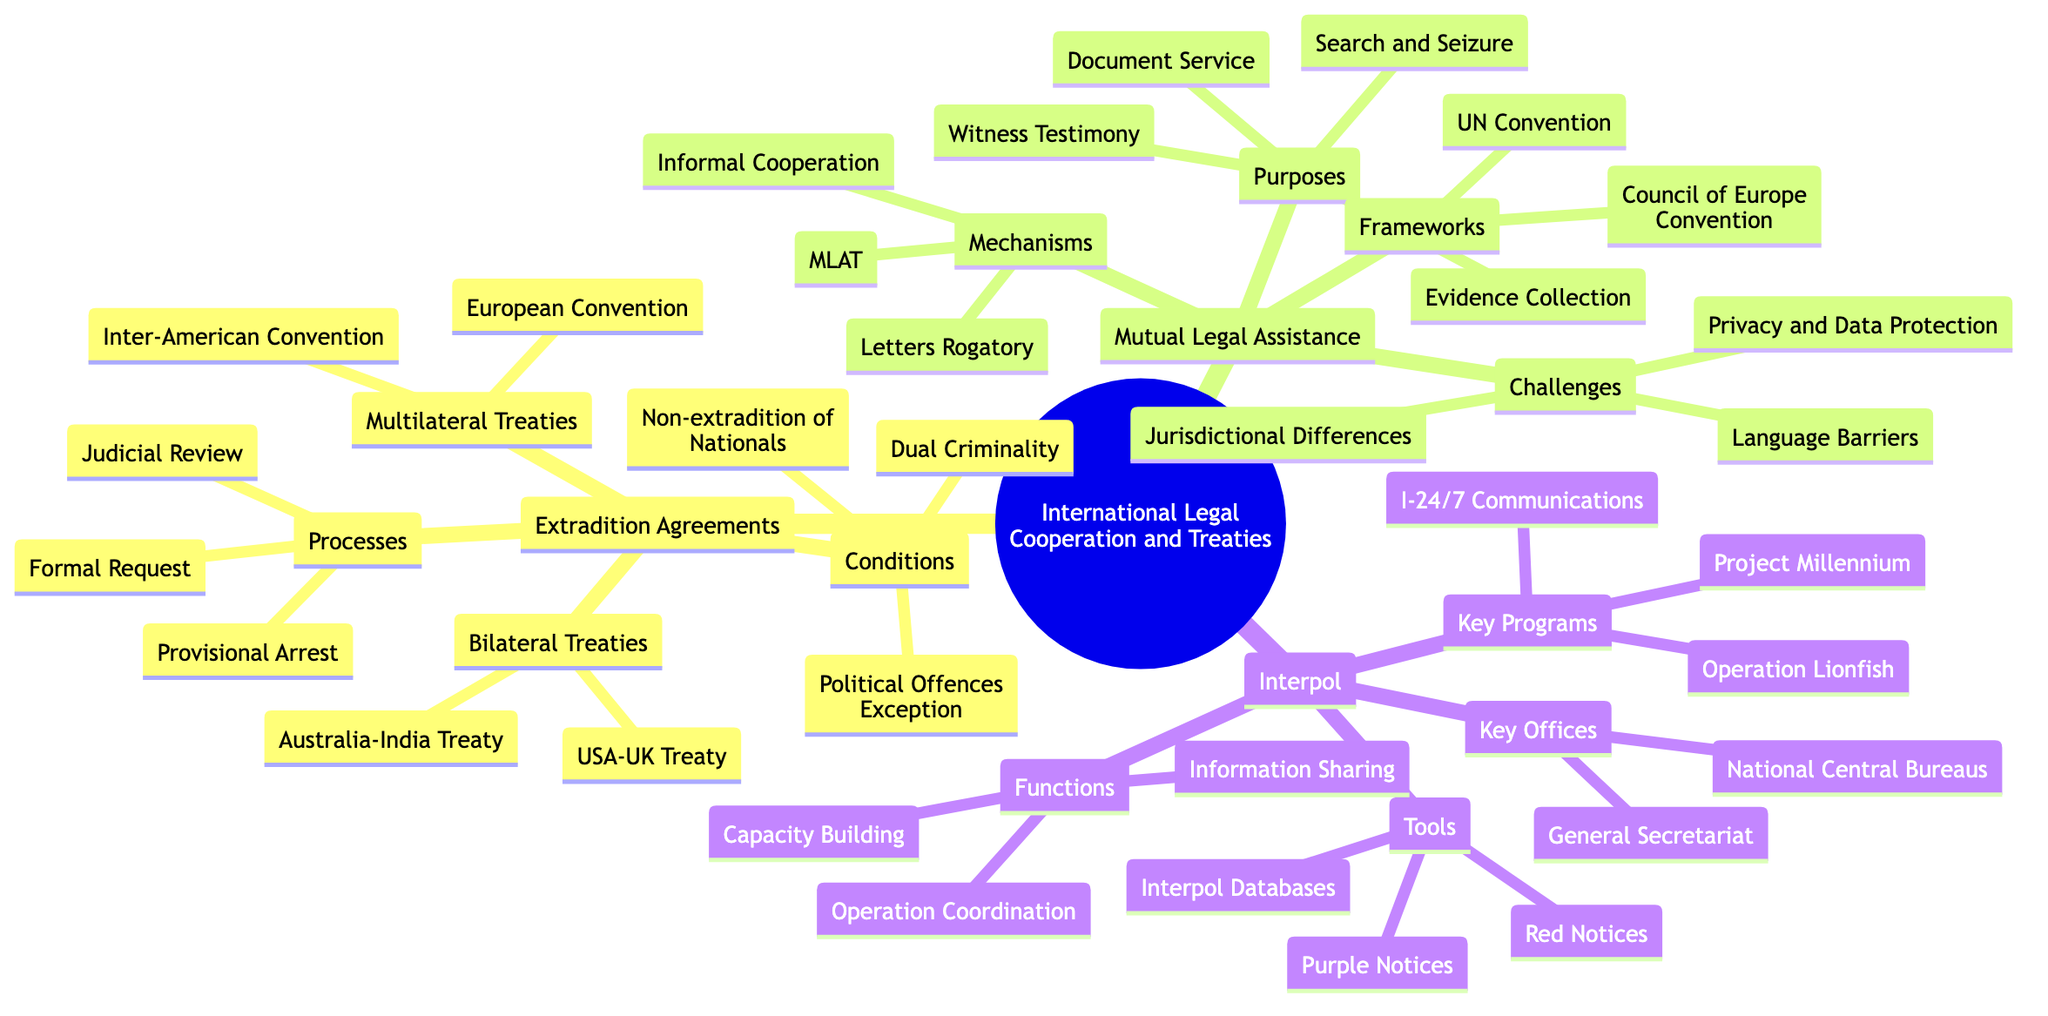What are two examples of Bilateral Treaties? The diagram lists specific examples under the "Bilateral Treaties" sub-branch. They are "USA-UK Extradition Treaty" and "Australia-India Extradition Treaty."
Answer: USA-UK Extradition Treaty, Australia-India Extradition Treaty What are the two types of treaties mentioned? The diagram explicitly states two main categories for treaties under "Extradition Agreements": "Bilateral Treaties" and "Multilateral Treaties."
Answer: Bilateral Treaties, Multilateral Treaties What is meant by "Dual Criminality"? "Dual Criminality" is mentioned as one of the conditions for extradition agreements. This reflects a principle whereby the act for which extradition is requested must be a crime in both involved countries.
Answer: A condition in extradition agreements How many challenges are listed under Mutual Legal Assistance? The diagram outlines three challenges under the "Challenges" sub-branch. They are "Jurisdictional Differences," "Privacy and Data Protection," and "Language Barriers."
Answer: Three What is one purpose of Mutual Legal Assistance? The diagram categories that explain the purposes of mutual legal assistance include "Collection of Evidence," "Service of Documents," "Search and Seizure," and "Witness Testimony." Any one of these would answer the question.
Answer: Collection of Evidence What is the function of Interpol mentioned in the diagram? The diagram identifies three functions of Interpol, specifically "Criminal Information Sharing," "Coordination of International Operations," and "Capacity Building and Training." Any of these can be cited as a function.
Answer: Criminal Information Sharing What is a common mechanism for Mutual Legal Assistance? Under the "Mechanisms" sub-branch for Mutual Legal Assistance, "MLAT (Mutual Legal Assistance Treaty)" is explicitly mentioned as one of the mechanisms.
Answer: MLAT What tools does Interpol use? The diagram provides three tools under the "Tools" sub-branch: "Red Notices," "Purple Notices," and "Interpol Databases." Any of these would suit the question.
Answer: Red Notices, Purple Notices, Interpol Databases What is a key program of Interpol? The diagram lists three key programs for Interpol, one of which is "Operation Lionfish." Any program could serve as a valid answer.
Answer: Operation Lionfish 